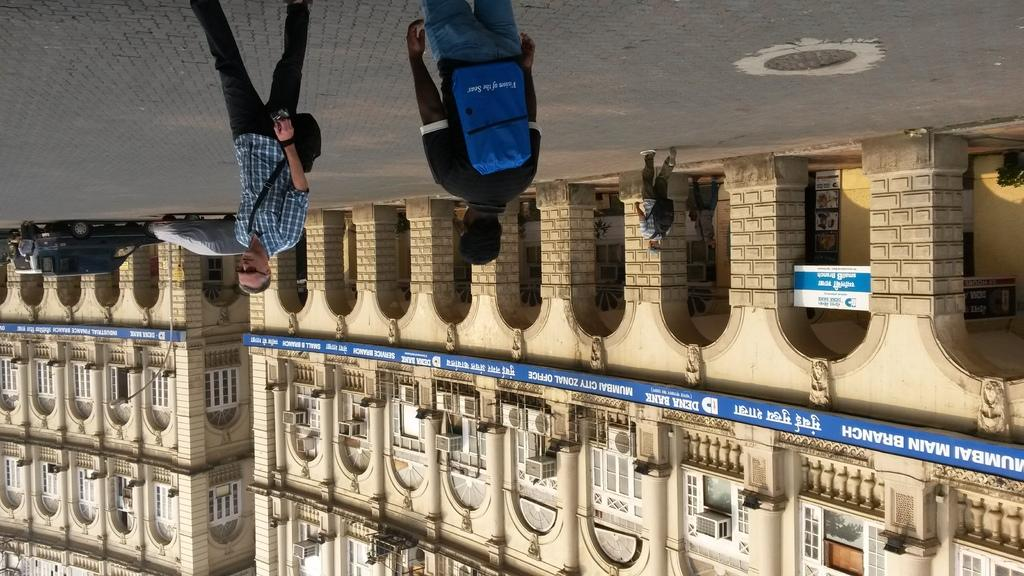What are the people in the image doing? There are persons walking on the road in the image. What else can be seen in the image besides the people walking? There are parked vehicles in the image. Can you see any yams growing near the lake in the image? There is no lake or yams present in the image; it features people walking on the road and parked vehicles. 